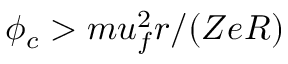Convert formula to latex. <formula><loc_0><loc_0><loc_500><loc_500>\phi _ { c } > m u _ { f } ^ { 2 } r / ( Z e R )</formula> 